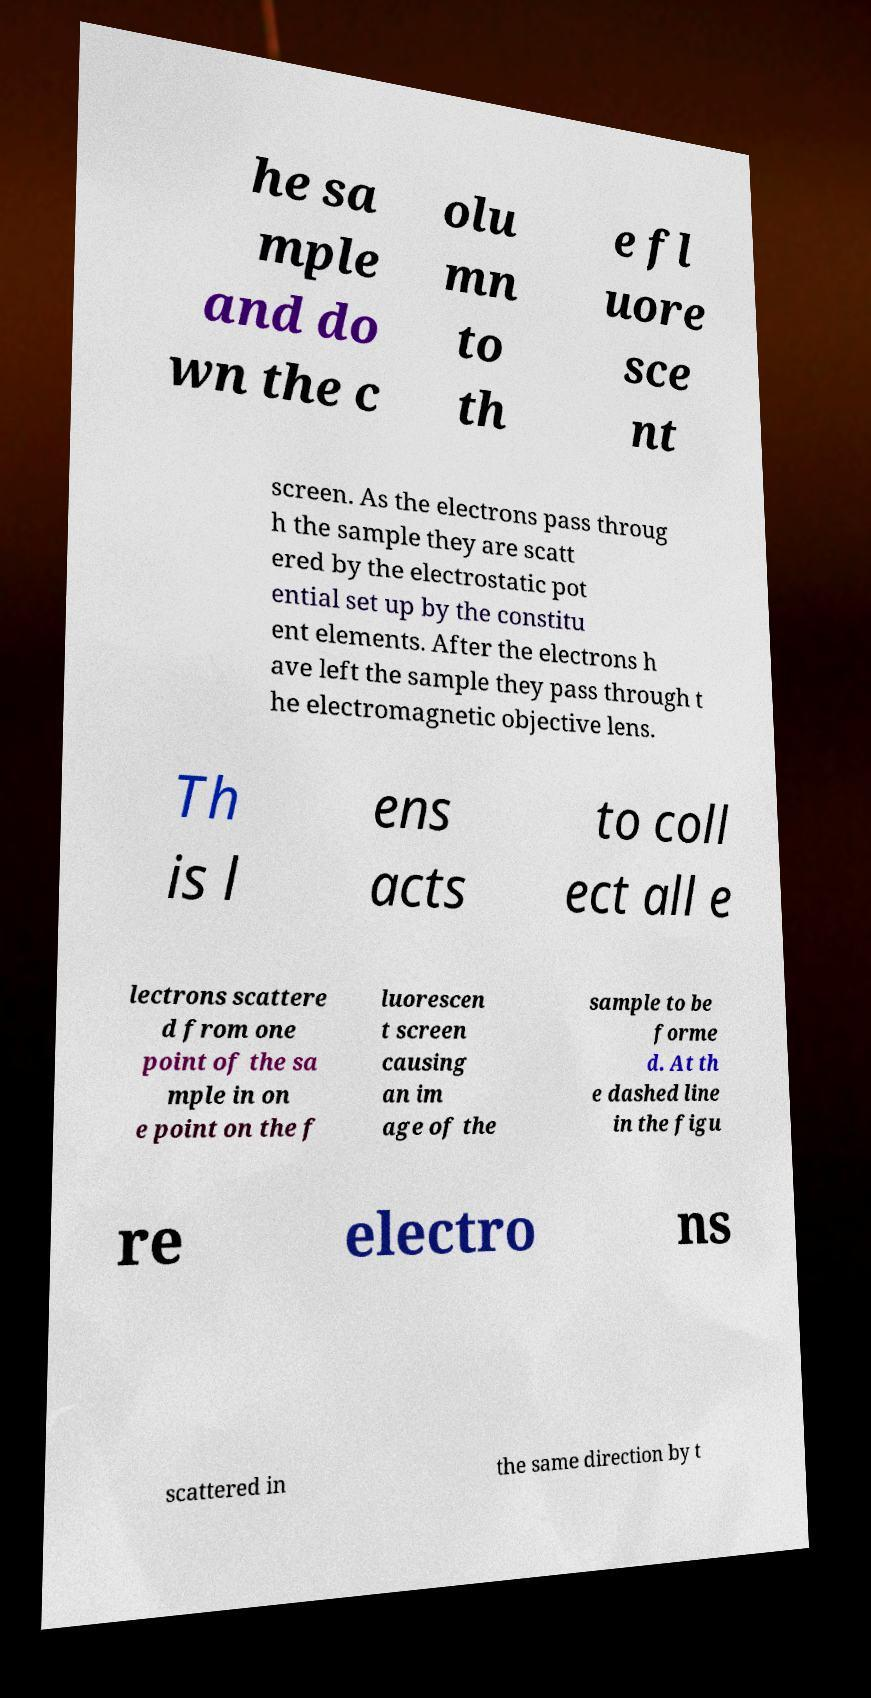Please identify and transcribe the text found in this image. he sa mple and do wn the c olu mn to th e fl uore sce nt screen. As the electrons pass throug h the sample they are scatt ered by the electrostatic pot ential set up by the constitu ent elements. After the electrons h ave left the sample they pass through t he electromagnetic objective lens. Th is l ens acts to coll ect all e lectrons scattere d from one point of the sa mple in on e point on the f luorescen t screen causing an im age of the sample to be forme d. At th e dashed line in the figu re electro ns scattered in the same direction by t 